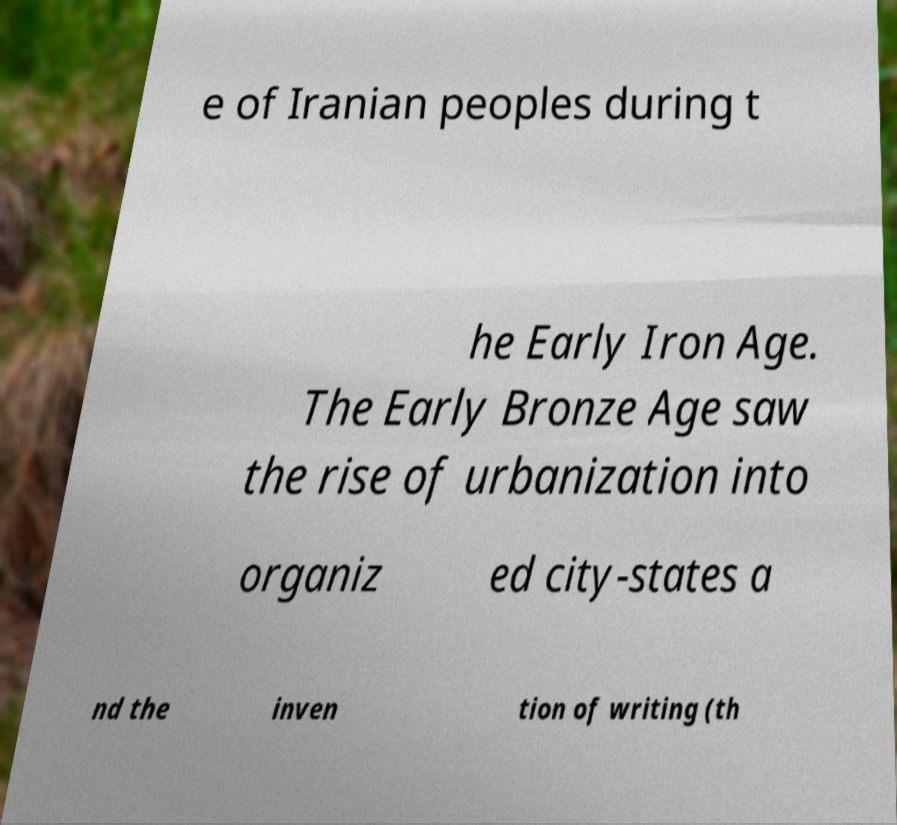What messages or text are displayed in this image? I need them in a readable, typed format. e of Iranian peoples during t he Early Iron Age. The Early Bronze Age saw the rise of urbanization into organiz ed city-states a nd the inven tion of writing (th 